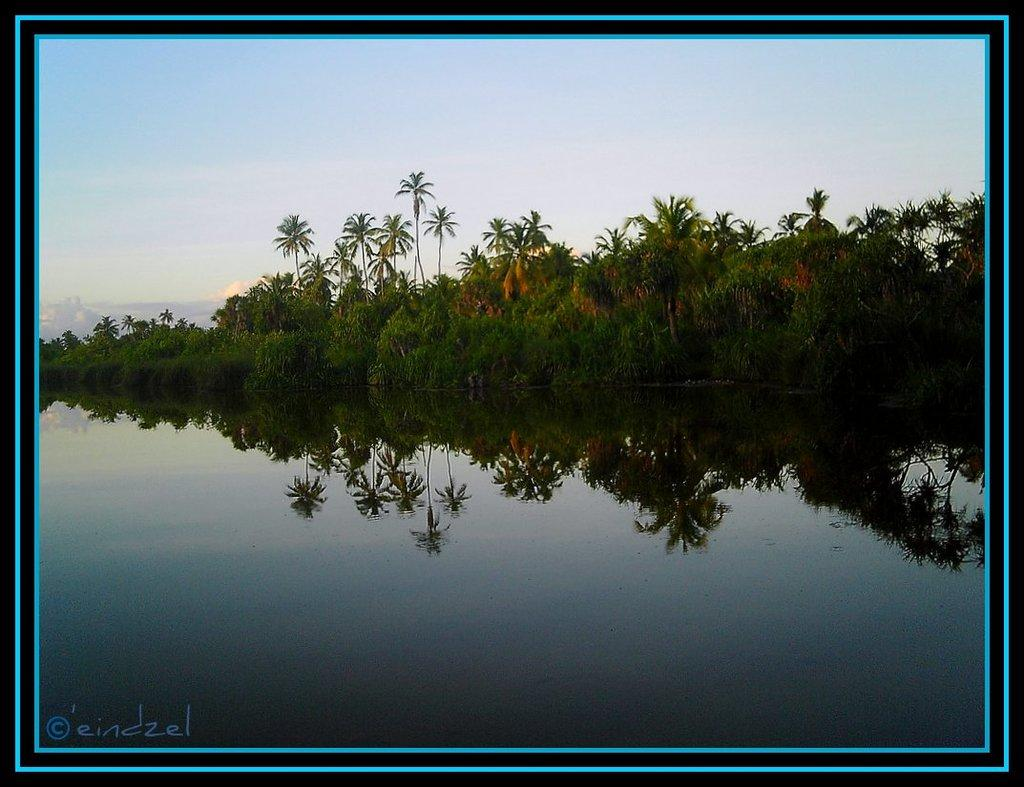What type of natural feature is present in the image? There is a water body in the image. What other natural elements can be seen in the image? There is a group of trees in the image. What is visible in the background of the image? The sky is visible in the image. How would you describe the sky in the image? The sky appears to be cloudy. What type of cherry is being attacked by a wild animal in the image? There is no cherry or wild animal present in the image. 